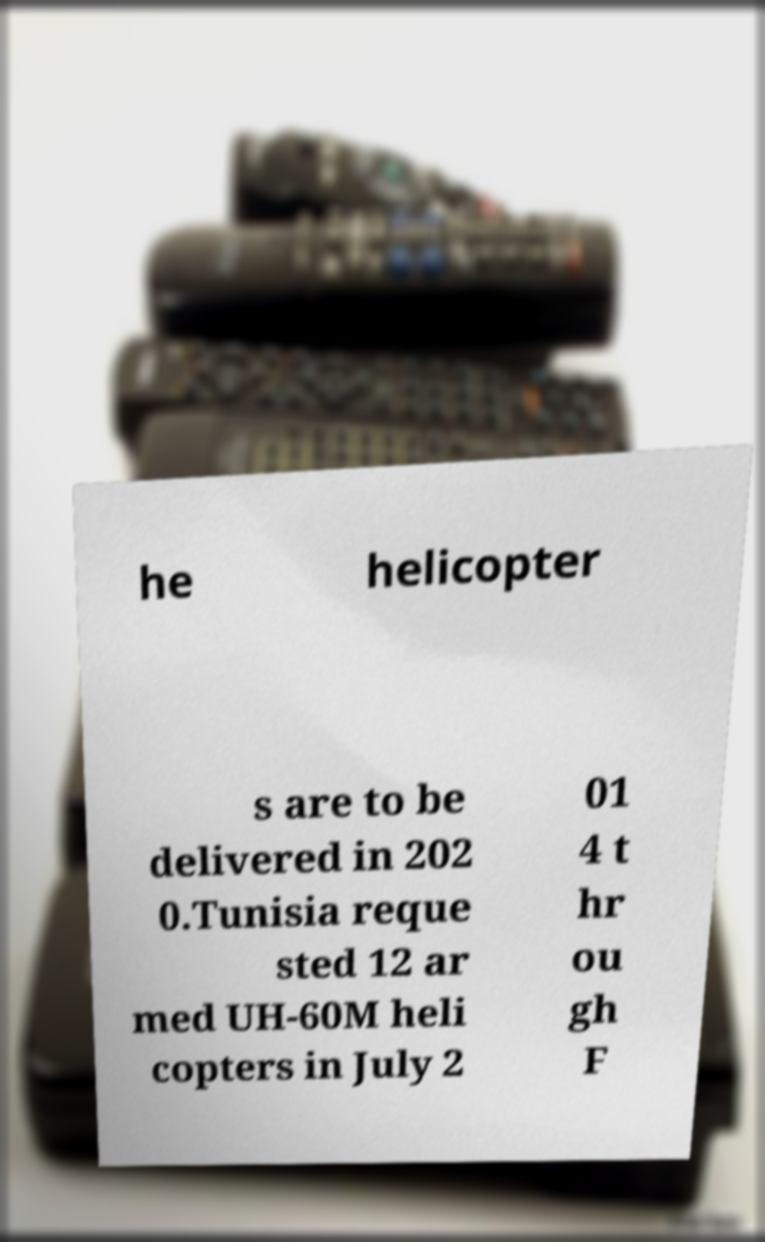I need the written content from this picture converted into text. Can you do that? he helicopter s are to be delivered in 202 0.Tunisia reque sted 12 ar med UH-60M heli copters in July 2 01 4 t hr ou gh F 